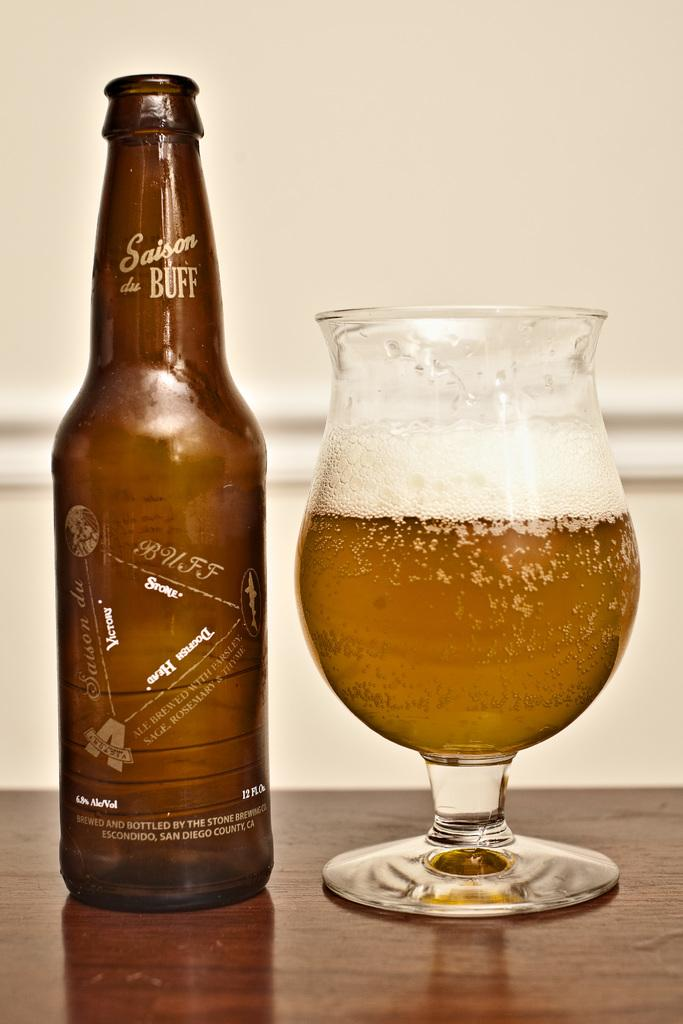<image>
Share a concise interpretation of the image provided. A bottle of Saison du Buff next to a full glass. 